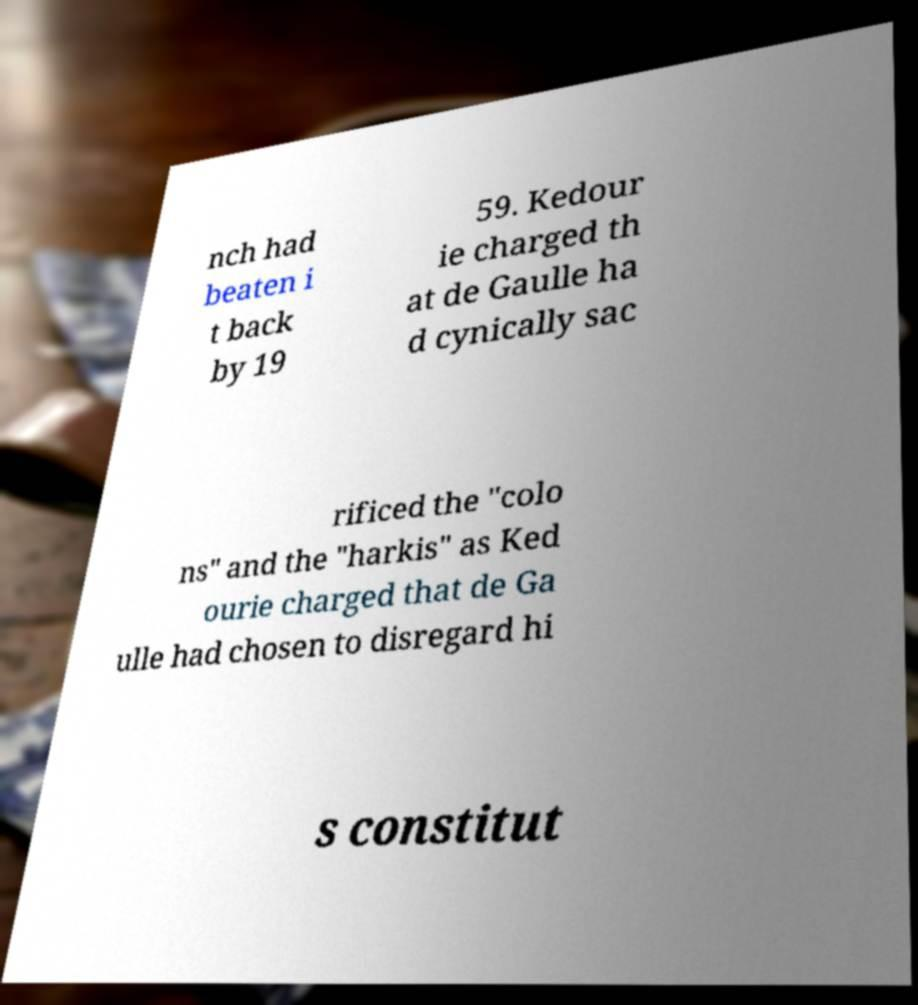There's text embedded in this image that I need extracted. Can you transcribe it verbatim? nch had beaten i t back by 19 59. Kedour ie charged th at de Gaulle ha d cynically sac rificed the "colo ns" and the "harkis" as Ked ourie charged that de Ga ulle had chosen to disregard hi s constitut 